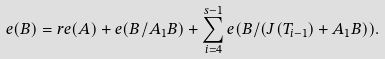<formula> <loc_0><loc_0><loc_500><loc_500>e ( B ) = r e ( A ) + e ( B / A _ { 1 } B ) + \sum _ { i = 4 } ^ { s - 1 } e ( B / ( J ( T _ { i - 1 } ) + A _ { 1 } B ) ) .</formula> 